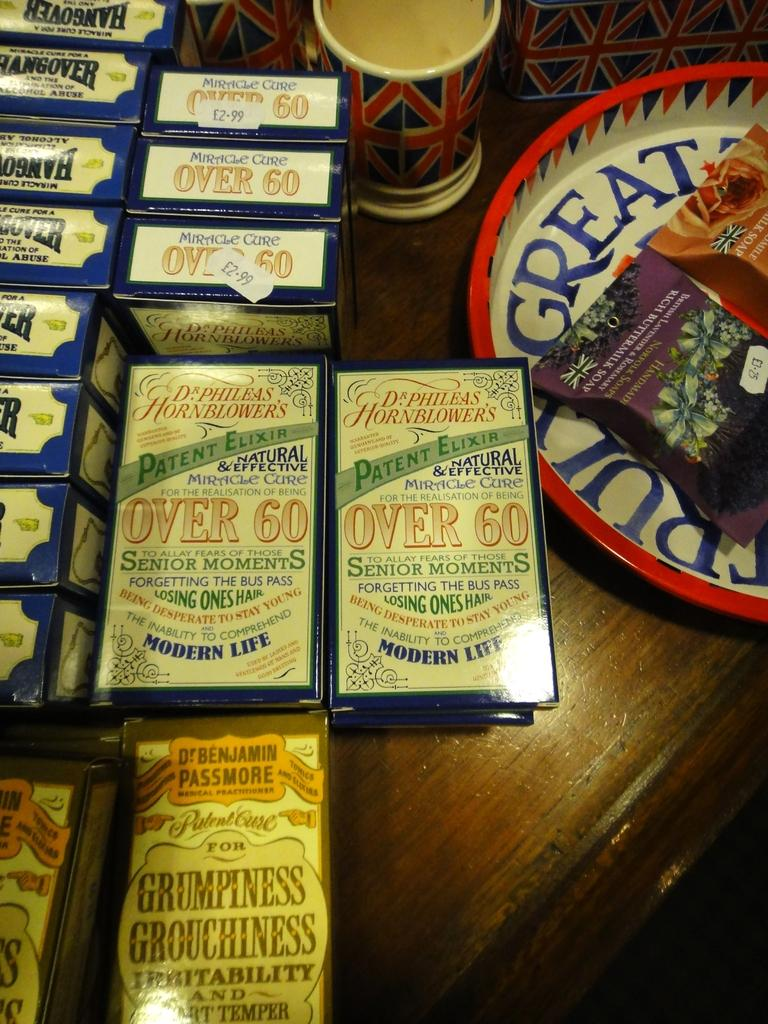<image>
Create a compact narrative representing the image presented. lots of boxes of over 60 sebior moments 